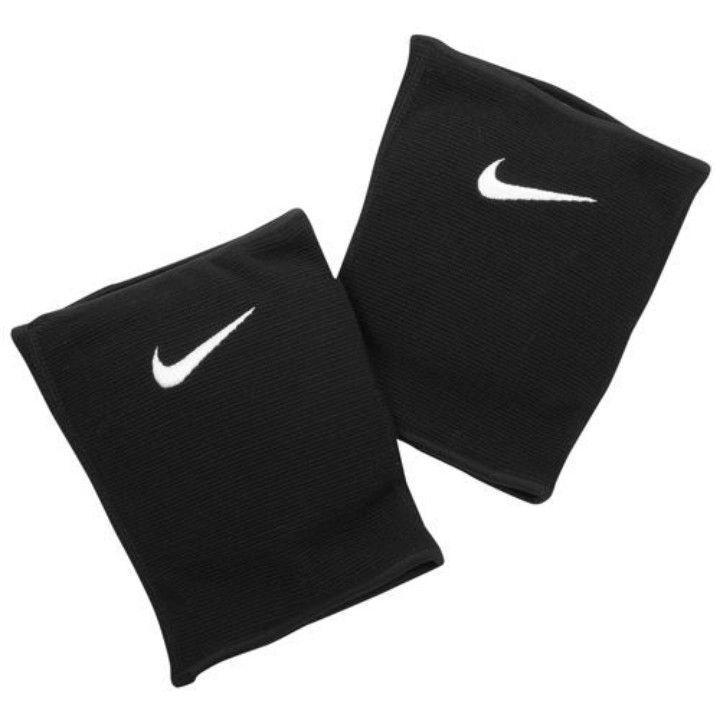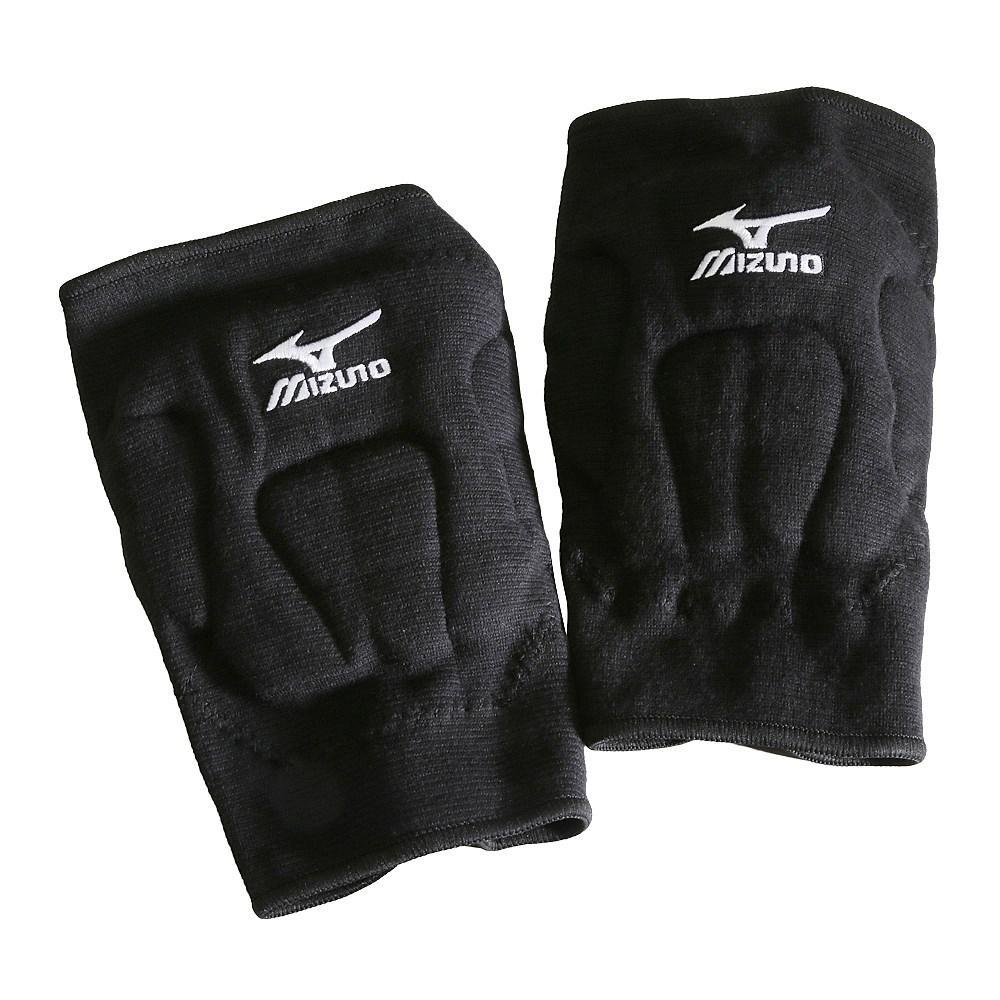The first image is the image on the left, the second image is the image on the right. Analyze the images presented: Is the assertion "There are two pairs of knee pads laying flat." valid? Answer yes or no. Yes. The first image is the image on the left, the second image is the image on the right. Considering the images on both sides, is "Each image contains one pair of black knee pads, but only one image features a pair of knee pads with logos visible on each pad." valid? Answer yes or no. No. 